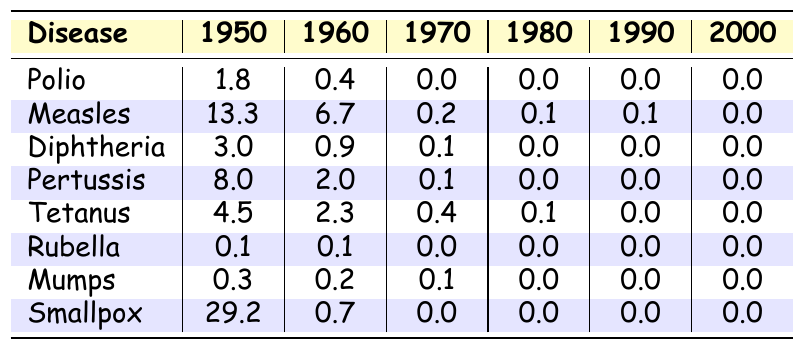What was the mortality rate for measles in 1950? The table clearly shows that the mortality rate for measles in 1950 was 13.3.
Answer: 13.3 What is the mortality rate for smallpox in 2000? According to the table, the mortality rate for smallpox in 2000 is 0.0.
Answer: 0.0 Which disease had the highest mortality rate in 1950? Looking at the table, smallpox had the highest mortality rate in 1950 at 29.2.
Answer: Smallpox What disease saw the most significant reduction in mortality rate from 1950 to 2000? Analyzing the data, both smallpox and measles reduced from 29.2 and 13.3 to 0.0, respectively. However, smallpox's initial rate was higher, so it saw the most considerable absolute reduction.
Answer: Smallpox How many diseases had a mortality rate of 0.0 in 2000? From the table, we see that all diseases listed had a mortality rate of 0.0 in 2000. This means there are 8 diseases accounted for.
Answer: 8 Calculate the average mortality rate for diphtheria over the years listed. The mortality rates for diphtheria across the years are 3.0 (1950), 0.9 (1960), 0.1 (1970), 0.0 (1980), 0.0 (1990), and 0.0 (2000). Summing these gives (3.0 + 0.9 + 0.1 + 0.0 + 0.0 + 0.0) = 4.0, and dividing by 6 years, the average is 4.0 / 6 = 0.67.
Answer: 0.67 True or False: The mortality rate for rubella was higher in 1960 than in 1950. The table indicates that the mortality rate for rubella was 0.1 in both 1950 and 1960, so it did not increase. Therefore, the statement is False.
Answer: False What was the overall trend in mortality rates for childhood diseases from 1950 to 2000? Examining the table, it is clear that mortality rates for all listed diseases consistently decreased from 1950 down to 2000, indicating a positive trend in public health through the introduction of vaccines.
Answer: Decreasing Which disease had the lowest mortality rate in 1980? In the table for the year 1980, the mortality rates show that both rubella, mumps, and smallpox had rates of 0.0, but since they are all tied, the lowest is realized at 0.0 for these diseases.
Answer: Rubella, Mumps, Smallpox If we compare the mortality rates of pertussis in 1950 and 1970, how much did it decrease? The rate for pertussis in 1950 was 8.0 and in 1970 was 0.1. The decrease can be calculated as 8.0 - 0.1 = 7.9, showing a significant decline.
Answer: 7.9 